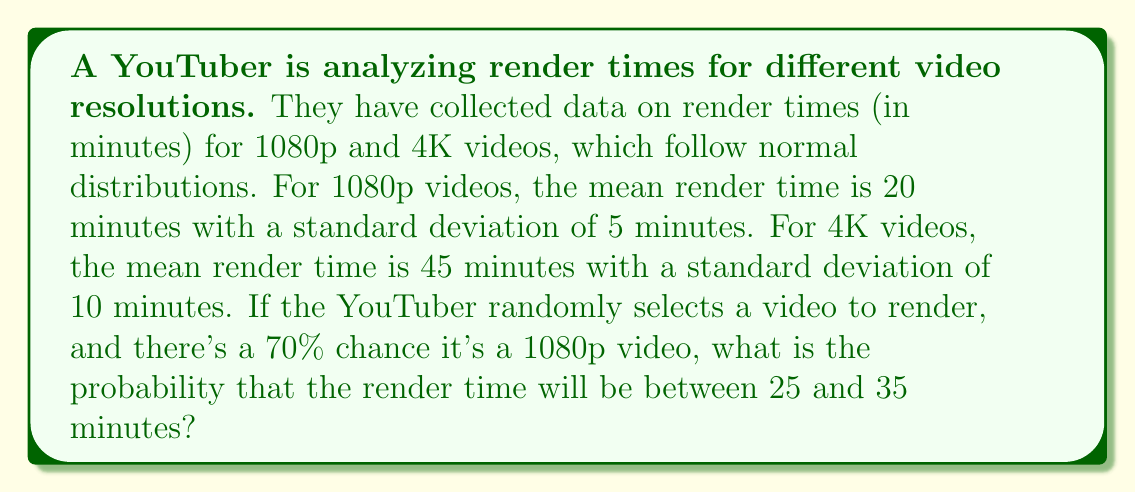Provide a solution to this math problem. Let's approach this step-by-step:

1) First, we need to recognize that this is a mixture of two normal distributions. Let's define:
   $X_1 \sim N(20, 5^2)$ for 1080p videos
   $X_2 \sim N(45, 10^2)$ for 4K videos

2) The probability of selecting a 1080p video is 0.7, so the probability of selecting a 4K video is 0.3.

3) We need to find $P(25 < X < 35)$, where X is our mixed distribution.

4) We can use the law of total probability:
   $P(25 < X < 35) = P(25 < X < 35 | 1080p) \cdot P(1080p) + P(25 < X < 35 | 4K) \cdot P(4K)$

5) For 1080p videos:
   $P(25 < X_1 < 35) = P(\frac{25-20}{5} < Z < \frac{35-20}{5}) = P(1 < Z < 3)$
   $= \Phi(3) - \Phi(1) = 0.9987 - 0.8413 = 0.1574$

6) For 4K videos:
   $P(25 < X_2 < 35) = P(\frac{25-45}{10} < Z < \frac{35-45}{10}) = P(-2 < Z < -1)$
   $= \Phi(-1) - \Phi(-2) = 0.1587 - 0.0228 = 0.1359$

7) Putting it all together:
   $P(25 < X < 35) = 0.1574 \cdot 0.7 + 0.1359 \cdot 0.3 = 0.1102 + 0.0408 = 0.1510$
Answer: 0.1510 or 15.10% 